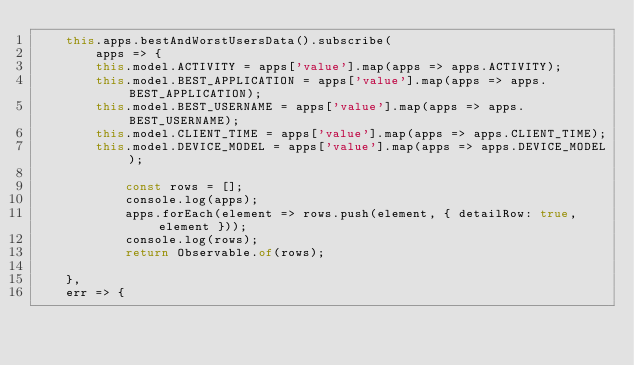<code> <loc_0><loc_0><loc_500><loc_500><_TypeScript_>    this.apps.bestAndWorstUsersData().subscribe(
        apps => {
        this.model.ACTIVITY = apps['value'].map(apps => apps.ACTIVITY);
        this.model.BEST_APPLICATION = apps['value'].map(apps => apps.BEST_APPLICATION);
        this.model.BEST_USERNAME = apps['value'].map(apps => apps.BEST_USERNAME);
        this.model.CLIENT_TIME = apps['value'].map(apps => apps.CLIENT_TIME);
        this.model.DEVICE_MODEL = apps['value'].map(apps => apps.DEVICE_MODEL);

            const rows = [];
            console.log(apps);
            apps.forEach(element => rows.push(element, { detailRow: true, element }));
            console.log(rows);
            return Observable.of(rows);        
        
    },
    err => {</code> 